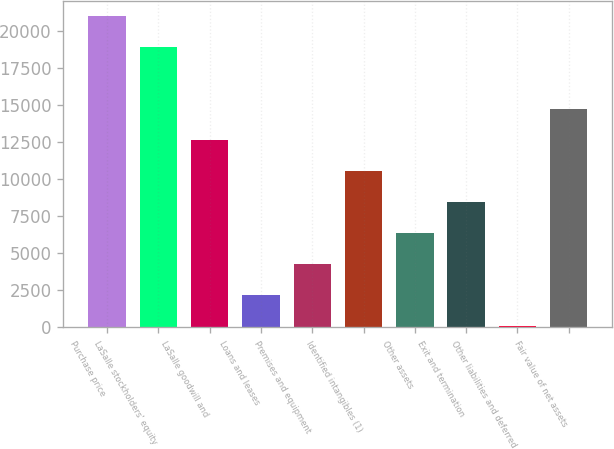Convert chart to OTSL. <chart><loc_0><loc_0><loc_500><loc_500><bar_chart><fcel>Purchase price<fcel>LaSalle stockholders' equity<fcel>LaSalle goodwill and<fcel>Loans and leases<fcel>Premises and equipment<fcel>Identified intangibles (1)<fcel>Other assets<fcel>Exit and termination<fcel>Other liabilities and deferred<fcel>Fair value of net assets<nl><fcel>21015<fcel>18920.7<fcel>12637.8<fcel>2166.3<fcel>4260.6<fcel>10543.5<fcel>6354.9<fcel>8449.2<fcel>72<fcel>14732.1<nl></chart> 